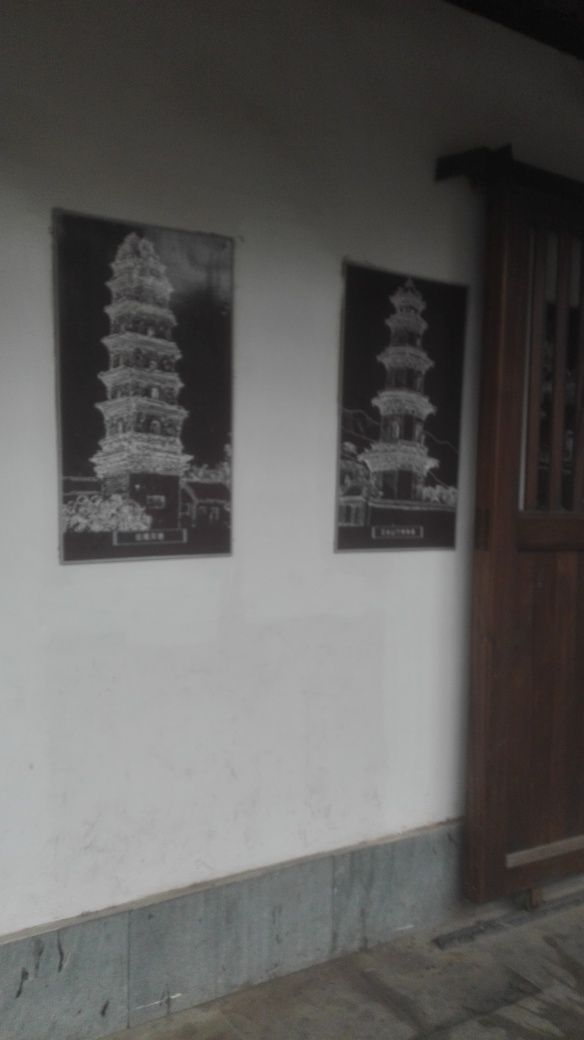Are there focusing issues in the image? Upon examining the image, it appears that there is a slight blur affecting the overall sharpness, which suggests that there are indeed minor focusing issues. This is especially noticeable around the text areas and edges of the objects in the photograph. 